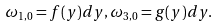<formula> <loc_0><loc_0><loc_500><loc_500>\omega _ { 1 , 0 } = f ( y ) d y , \omega _ { 3 , 0 } = g ( y ) d y .</formula> 